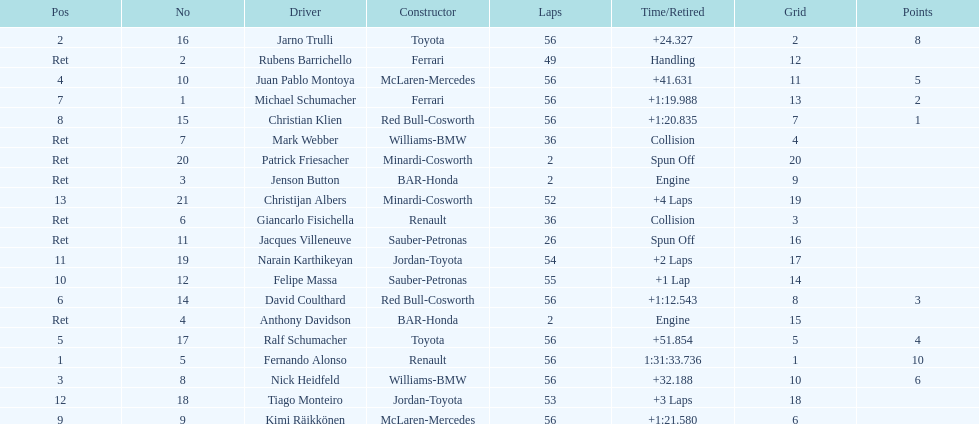Who was the last driver from the uk to actually finish the 56 laps? David Coulthard. 